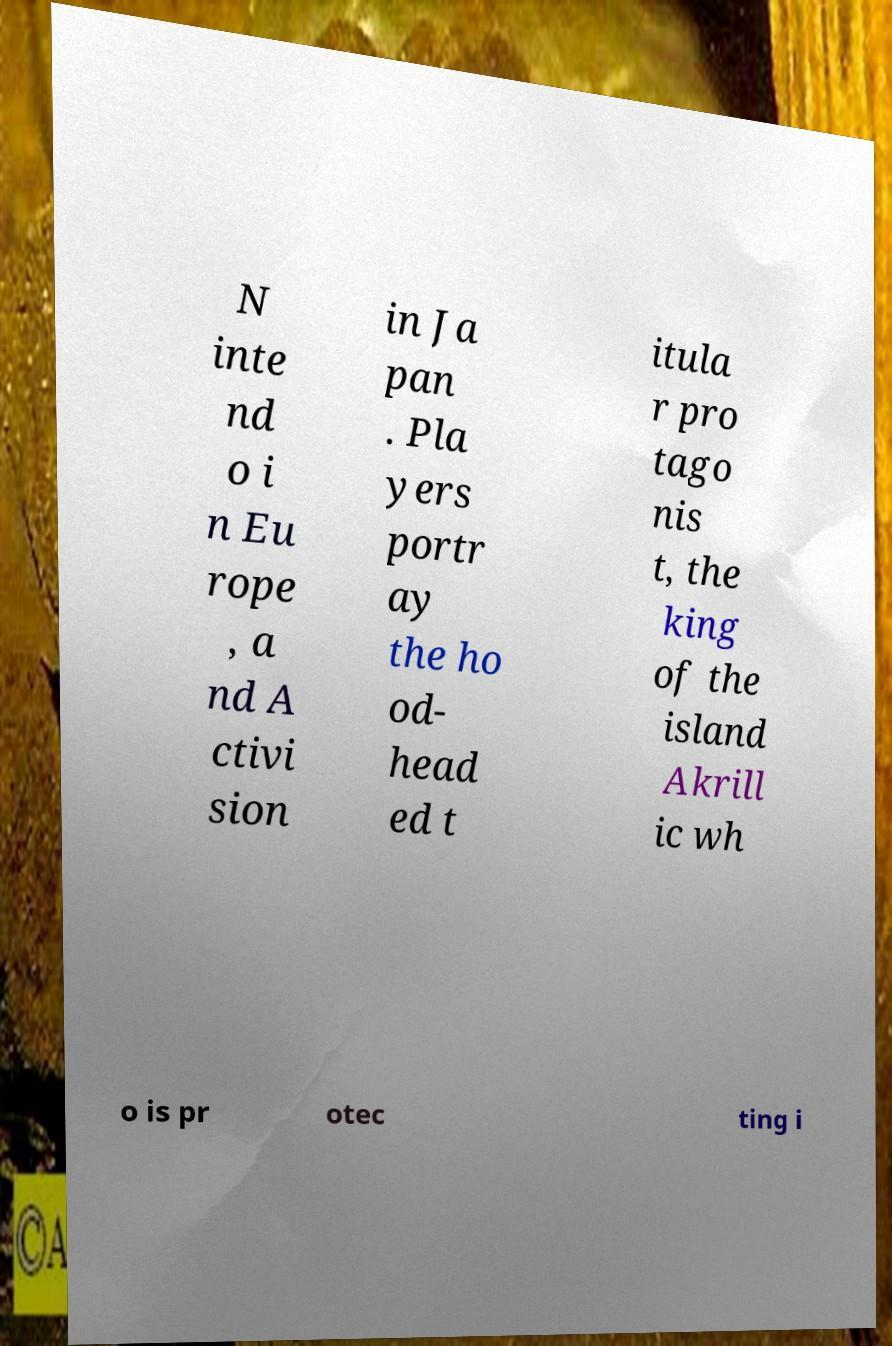Please identify and transcribe the text found in this image. N inte nd o i n Eu rope , a nd A ctivi sion in Ja pan . Pla yers portr ay the ho od- head ed t itula r pro tago nis t, the king of the island Akrill ic wh o is pr otec ting i 